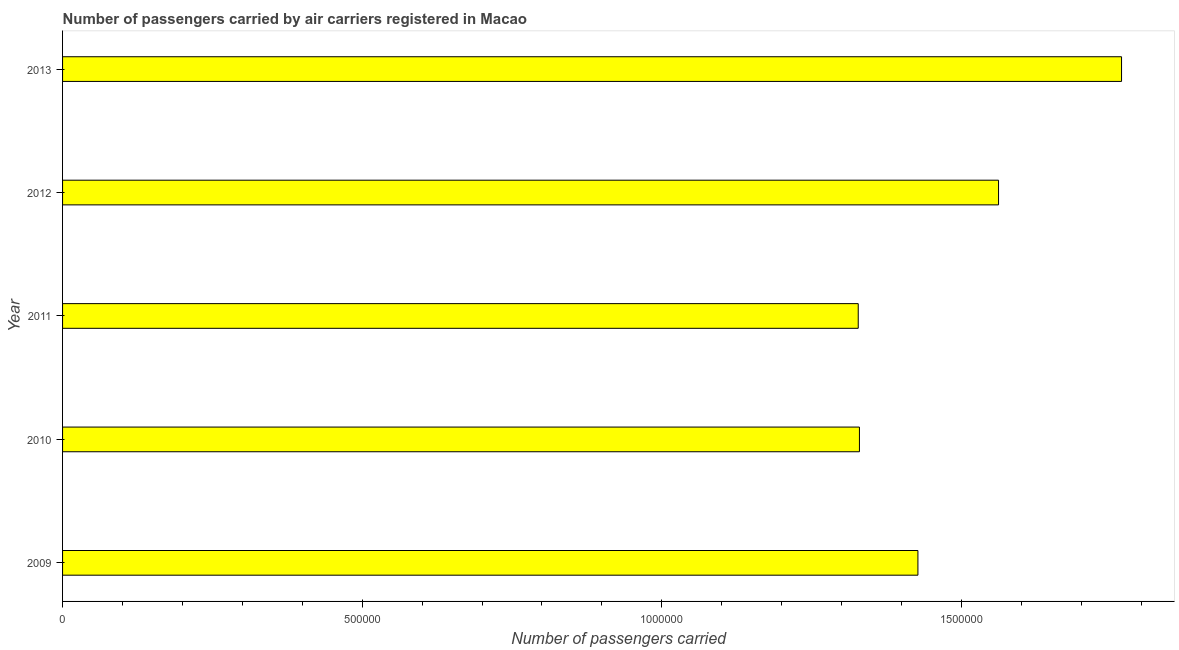Does the graph contain any zero values?
Provide a short and direct response. No. What is the title of the graph?
Your answer should be very brief. Number of passengers carried by air carriers registered in Macao. What is the label or title of the X-axis?
Keep it short and to the point. Number of passengers carried. What is the number of passengers carried in 2012?
Ensure brevity in your answer.  1.56e+06. Across all years, what is the maximum number of passengers carried?
Keep it short and to the point. 1.77e+06. Across all years, what is the minimum number of passengers carried?
Your response must be concise. 1.33e+06. In which year was the number of passengers carried minimum?
Ensure brevity in your answer.  2011. What is the sum of the number of passengers carried?
Your answer should be compact. 7.41e+06. What is the difference between the number of passengers carried in 2009 and 2013?
Provide a succinct answer. -3.40e+05. What is the average number of passengers carried per year?
Provide a succinct answer. 1.48e+06. What is the median number of passengers carried?
Your response must be concise. 1.43e+06. In how many years, is the number of passengers carried greater than 1700000 ?
Provide a succinct answer. 1. Do a majority of the years between 2009 and 2011 (inclusive) have number of passengers carried greater than 1000000 ?
Offer a terse response. Yes. Is the number of passengers carried in 2010 less than that in 2013?
Provide a succinct answer. Yes. Is the difference between the number of passengers carried in 2009 and 2010 greater than the difference between any two years?
Make the answer very short. No. What is the difference between the highest and the second highest number of passengers carried?
Give a very brief answer. 2.05e+05. Is the sum of the number of passengers carried in 2009 and 2011 greater than the maximum number of passengers carried across all years?
Your answer should be compact. Yes. What is the difference between the highest and the lowest number of passengers carried?
Give a very brief answer. 4.39e+05. In how many years, is the number of passengers carried greater than the average number of passengers carried taken over all years?
Give a very brief answer. 2. How many bars are there?
Your answer should be compact. 5. How many years are there in the graph?
Provide a short and direct response. 5. What is the Number of passengers carried of 2009?
Offer a terse response. 1.43e+06. What is the Number of passengers carried of 2010?
Provide a succinct answer. 1.33e+06. What is the Number of passengers carried in 2011?
Your answer should be compact. 1.33e+06. What is the Number of passengers carried of 2012?
Keep it short and to the point. 1.56e+06. What is the Number of passengers carried of 2013?
Make the answer very short. 1.77e+06. What is the difference between the Number of passengers carried in 2009 and 2010?
Ensure brevity in your answer.  9.76e+04. What is the difference between the Number of passengers carried in 2009 and 2011?
Ensure brevity in your answer.  9.96e+04. What is the difference between the Number of passengers carried in 2009 and 2012?
Your answer should be very brief. -1.35e+05. What is the difference between the Number of passengers carried in 2009 and 2013?
Provide a short and direct response. -3.40e+05. What is the difference between the Number of passengers carried in 2010 and 2011?
Provide a short and direct response. 1989. What is the difference between the Number of passengers carried in 2010 and 2012?
Your answer should be very brief. -2.32e+05. What is the difference between the Number of passengers carried in 2010 and 2013?
Offer a terse response. -4.37e+05. What is the difference between the Number of passengers carried in 2011 and 2012?
Provide a short and direct response. -2.34e+05. What is the difference between the Number of passengers carried in 2011 and 2013?
Ensure brevity in your answer.  -4.39e+05. What is the difference between the Number of passengers carried in 2012 and 2013?
Your answer should be compact. -2.05e+05. What is the ratio of the Number of passengers carried in 2009 to that in 2010?
Provide a succinct answer. 1.07. What is the ratio of the Number of passengers carried in 2009 to that in 2011?
Offer a very short reply. 1.07. What is the ratio of the Number of passengers carried in 2009 to that in 2012?
Your answer should be compact. 0.91. What is the ratio of the Number of passengers carried in 2009 to that in 2013?
Provide a succinct answer. 0.81. What is the ratio of the Number of passengers carried in 2010 to that in 2012?
Keep it short and to the point. 0.85. What is the ratio of the Number of passengers carried in 2010 to that in 2013?
Keep it short and to the point. 0.75. What is the ratio of the Number of passengers carried in 2011 to that in 2013?
Give a very brief answer. 0.75. What is the ratio of the Number of passengers carried in 2012 to that in 2013?
Keep it short and to the point. 0.88. 